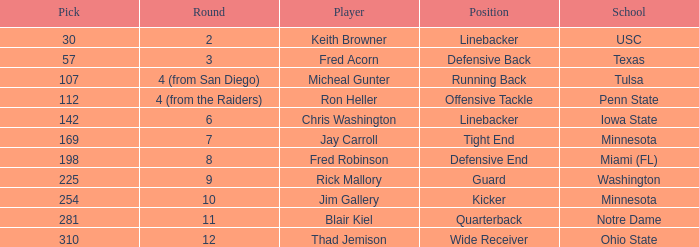What is the total pick number for a wide receiver? 1.0. 